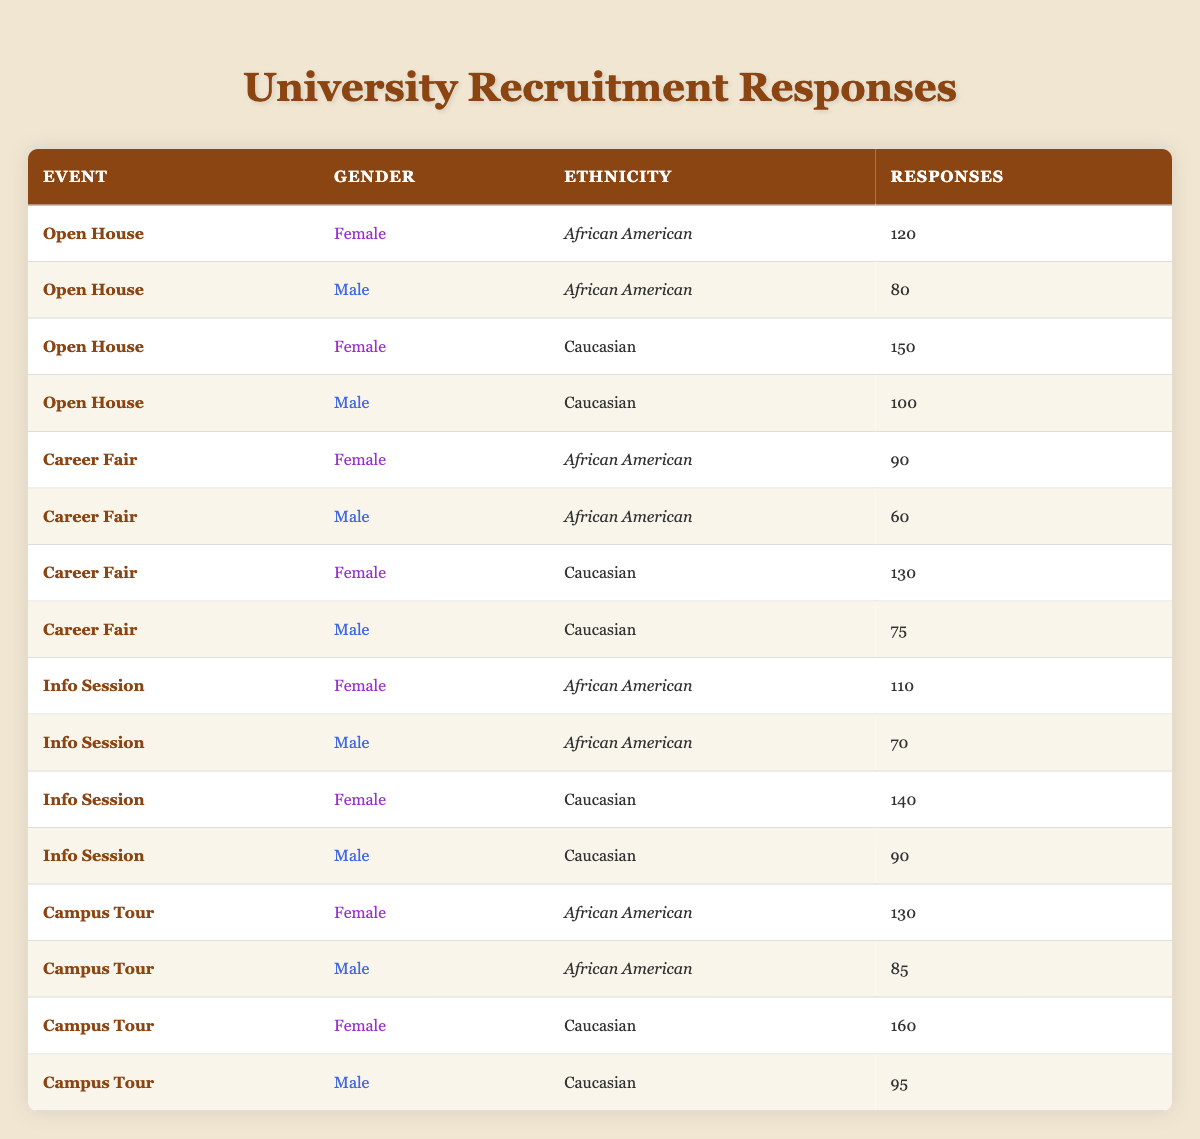What is the total number of responses from African American females across all events? The total responses from African American females are: Open House (120) + Career Fair (90) + Info Session (110) + Campus Tour (130) = 450.
Answer: 450 What event received the highest number of responses from Caucasian males? The responses from Caucasian males are: Open House (100), Career Fair (75), Info Session (90), Campus Tour (95). The highest value is 100 from the Open House.
Answer: 100 Did more African American females attend the Campus Tour compared to the Career Fair? Campus Tour responses from African American females are 130, while Career Fair responses are 90. Since 130 is greater than 90, the statement is true.
Answer: Yes What is the average number of responses from Caucasian females? The number of responses from Caucasian females are: Open House (150), Career Fair (130), Info Session (140), Campus Tour (160). The total is 150 + 130 + 140 + 160 = 580, and the average is 580/4 = 145.
Answer: 145 How many more responses did African American females have than males in the Info Session? In the Info Session, African American females had 110 responses while males had 70. The difference is 110 - 70 = 40.
Answer: 40 Which event had the least total responses from African American males? The responses from African American males are: Open House (80), Career Fair (60), Info Session (70), Campus Tour (85). The least number is 60 from the Career Fair.
Answer: Career Fair What percentage of responses from African American females were recorded at the Open House event? Total responses from African American females are 450, and those from the Open House are 120. Therefore, percentage calculation is (120/450) * 100 = 26.67% (rounded to two decimal places).
Answer: 26.67% In total, how many responses did Caucasian males receive across all events combined? The responses from Caucasian males are: Open House (100), Career Fair (75), Info Session (90), Campus Tour (95). Adding these gives: 100 + 75 + 90 + 95 = 360.
Answer: 360 